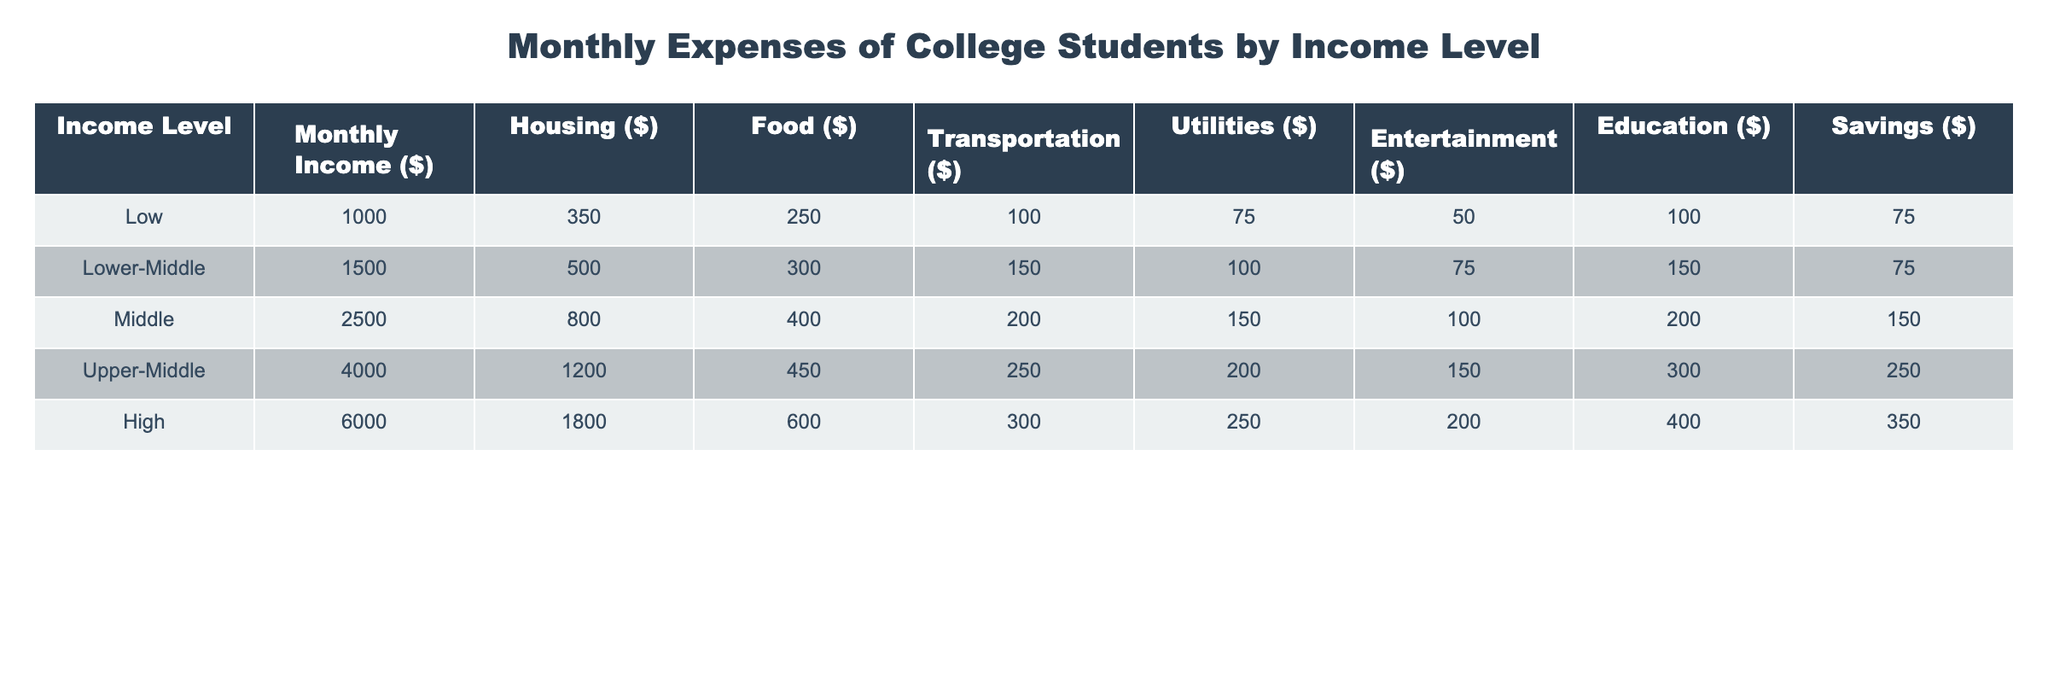What is the monthly housing expense for students in the Upper-Middle-income category? The table shows that for students categorized as Upper-Middle, the monthly housing expense is listed as $1200.
Answer: $1200 What is the total monthly food expense for students across all income levels? To find the total monthly food expense, add the food expenses for each income level: 250 + 300 + 400 + 450 + 600 = 2000.
Answer: $2000 Is the transportation expense for High-income students higher than that for Lower-Middle-income students? The table indicates that the transportation expense for High-income students is $300, while for Lower-Middle-income students, it's $150. Since 300 is greater than 150, the statement is true.
Answer: Yes How much more do Upper-Middle-income students spend on entertainment compared to Middle-income students? Upper-Middle-income students spend $200 on entertainment and Middle-income students spend $150. To find the difference, subtract: 200 - 150 = 50.
Answer: $50 What is the average savings for all income categories? To find the average savings, sum the savings across all income levels: 75 + 75 + 150 + 250 + 350 = 900. Then, divide by the number of income levels (5): 900 / 5 = 180.
Answer: $180 Do students in the Low-income category spend more on utilities than those in the Middle-income category? The table lists the utilities expense for Low-income students as $75 and for Middle-income students as $100. Since $75 is less than $100, the statement is false.
Answer: No What is the combined monthly expense for Housing and Utilities for the High-income group? The High-income group spends $1800 on housing and $300 on utilities. Adding these amounts gives a total of 1800 + 300 = 2100.
Answer: $2100 How does the monthly education expense for Upper-Middle-income students compare to that of Low-income students? Upper-Middle-income students have an education expense of $150, while Low-income students have $100. Thus, Upper-Middle-income students spend $50 more on education.
Answer: $50 more What is the percentage of total expenses spent on savings by Middle-income students relative to their total expenses? For Middle-income students, the total monthly expenses amount to $800 (Housing) + $400 (Food) + $200 (Transportation) + $100 (Utilities) + $150 (Entertainment) + $100 (Education) + $200 (Savings) = $2050. The savings of $200 as a percentage of $2050 is (200 / 2050) * 100 ≈ 9.76%.
Answer: 9.76% 